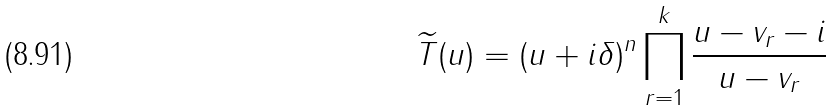Convert formula to latex. <formula><loc_0><loc_0><loc_500><loc_500>\widetilde { T } ( u ) = ( u + i \delta ) ^ { n } \prod _ { r = 1 } ^ { k } \frac { u - v _ { r } - i } { u - v _ { r } }</formula> 